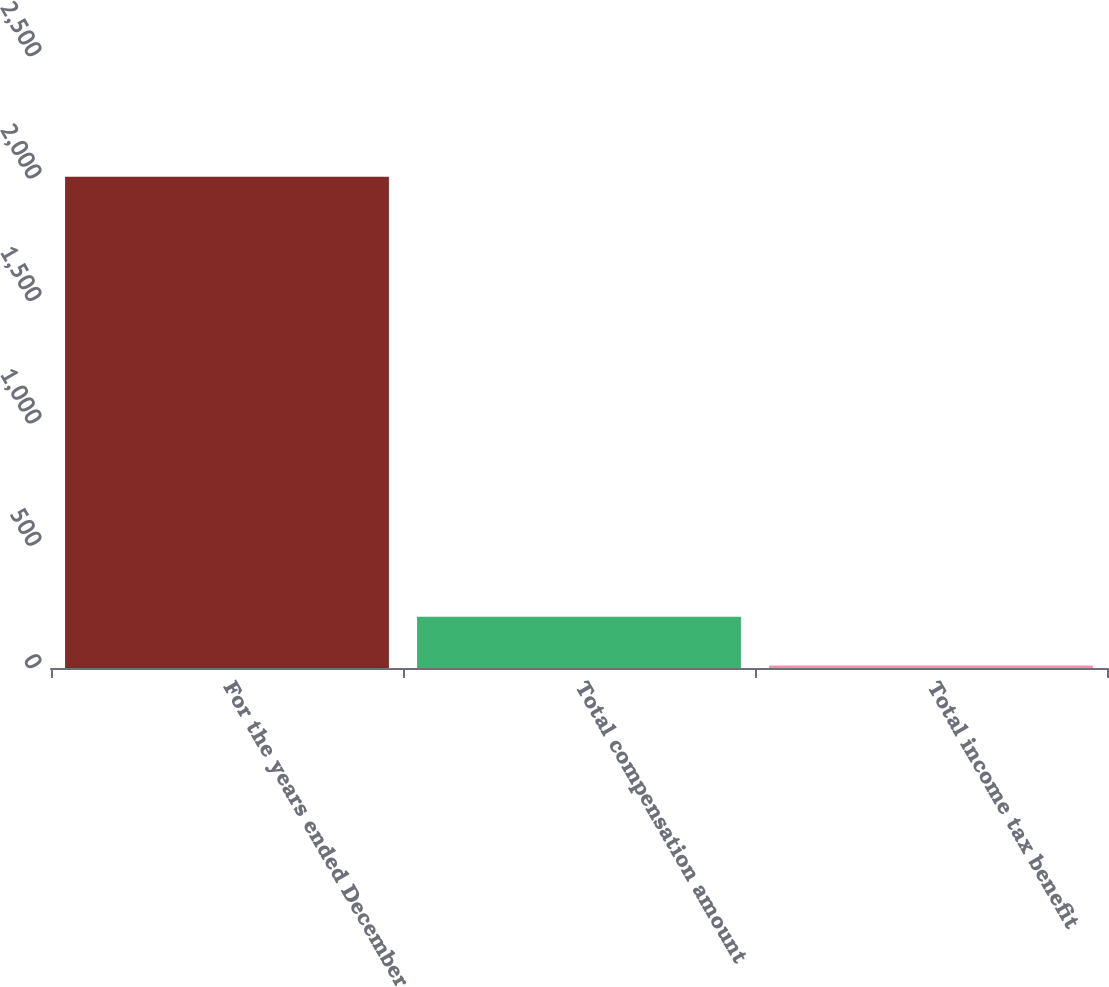Convert chart to OTSL. <chart><loc_0><loc_0><loc_500><loc_500><bar_chart><fcel>For the years ended December<fcel>Total compensation amount<fcel>Total income tax benefit<nl><fcel>2007<fcel>209.61<fcel>9.9<nl></chart> 